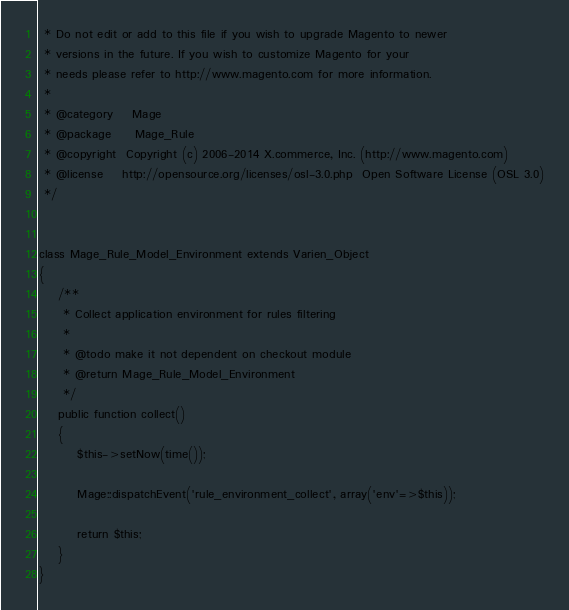<code> <loc_0><loc_0><loc_500><loc_500><_PHP_> * Do not edit or add to this file if you wish to upgrade Magento to newer
 * versions in the future. If you wish to customize Magento for your
 * needs please refer to http://www.magento.com for more information.
 *
 * @category    Mage
 * @package     Mage_Rule
 * @copyright  Copyright (c) 2006-2014 X.commerce, Inc. (http://www.magento.com)
 * @license    http://opensource.org/licenses/osl-3.0.php  Open Software License (OSL 3.0)
 */


class Mage_Rule_Model_Environment extends Varien_Object
{
    /**
     * Collect application environment for rules filtering
     *
     * @todo make it not dependent on checkout module
     * @return Mage_Rule_Model_Environment
     */
    public function collect()
    {
        $this->setNow(time());

        Mage::dispatchEvent('rule_environment_collect', array('env'=>$this));

        return $this;
    }
}
</code> 